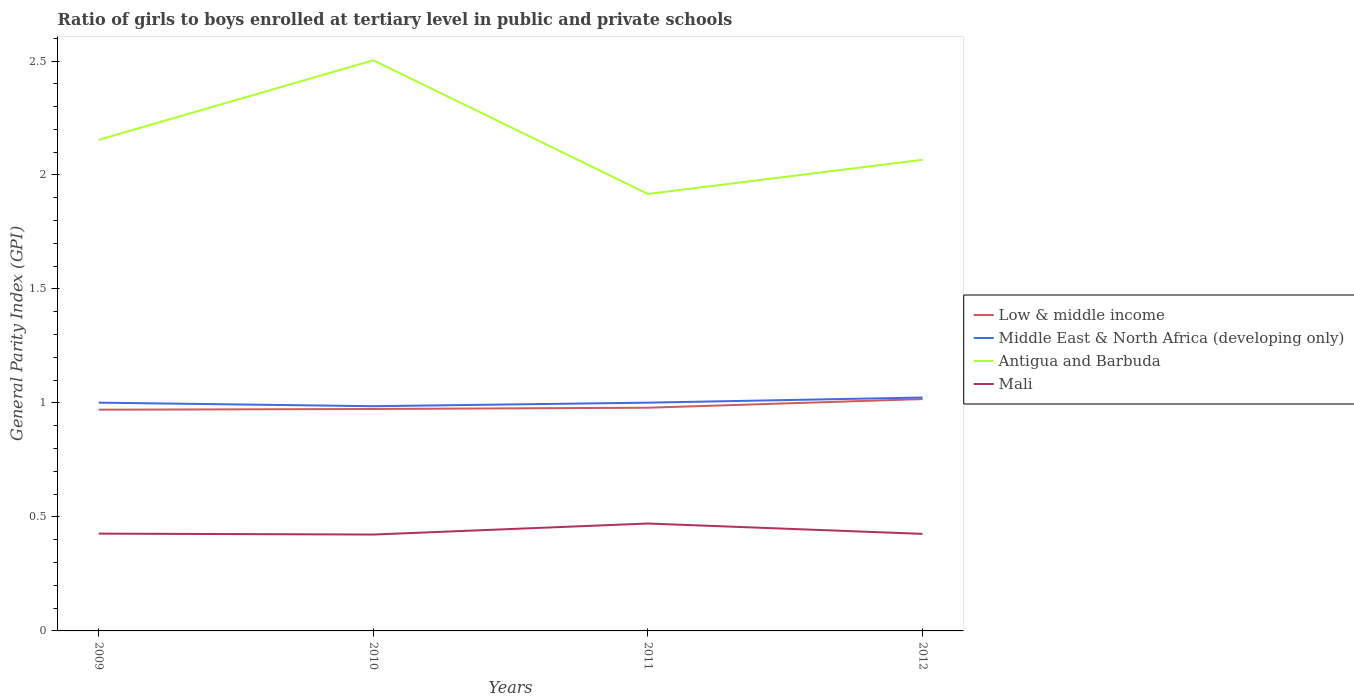Does the line corresponding to Middle East & North Africa (developing only) intersect with the line corresponding to Mali?
Provide a succinct answer. No. Is the number of lines equal to the number of legend labels?
Keep it short and to the point. Yes. Across all years, what is the maximum general parity index in Antigua and Barbuda?
Provide a succinct answer. 1.92. In which year was the general parity index in Low & middle income maximum?
Make the answer very short. 2009. What is the total general parity index in Low & middle income in the graph?
Provide a succinct answer. -0.04. What is the difference between the highest and the second highest general parity index in Low & middle income?
Provide a short and direct response. 0.05. What is the difference between the highest and the lowest general parity index in Antigua and Barbuda?
Provide a short and direct response. 1. Is the general parity index in Middle East & North Africa (developing only) strictly greater than the general parity index in Low & middle income over the years?
Give a very brief answer. No. How many lines are there?
Your response must be concise. 4. What is the difference between two consecutive major ticks on the Y-axis?
Provide a succinct answer. 0.5. Does the graph contain any zero values?
Ensure brevity in your answer.  No. Does the graph contain grids?
Your answer should be very brief. No. Where does the legend appear in the graph?
Your response must be concise. Center right. What is the title of the graph?
Ensure brevity in your answer.  Ratio of girls to boys enrolled at tertiary level in public and private schools. What is the label or title of the Y-axis?
Give a very brief answer. General Parity Index (GPI). What is the General Parity Index (GPI) in Low & middle income in 2009?
Ensure brevity in your answer.  0.97. What is the General Parity Index (GPI) of Middle East & North Africa (developing only) in 2009?
Provide a succinct answer. 1. What is the General Parity Index (GPI) of Antigua and Barbuda in 2009?
Provide a short and direct response. 2.15. What is the General Parity Index (GPI) in Mali in 2009?
Provide a short and direct response. 0.43. What is the General Parity Index (GPI) in Low & middle income in 2010?
Make the answer very short. 0.97. What is the General Parity Index (GPI) in Middle East & North Africa (developing only) in 2010?
Provide a succinct answer. 0.99. What is the General Parity Index (GPI) of Antigua and Barbuda in 2010?
Offer a very short reply. 2.5. What is the General Parity Index (GPI) in Mali in 2010?
Your response must be concise. 0.42. What is the General Parity Index (GPI) of Low & middle income in 2011?
Offer a very short reply. 0.98. What is the General Parity Index (GPI) of Middle East & North Africa (developing only) in 2011?
Ensure brevity in your answer.  1. What is the General Parity Index (GPI) of Antigua and Barbuda in 2011?
Ensure brevity in your answer.  1.92. What is the General Parity Index (GPI) of Mali in 2011?
Your response must be concise. 0.47. What is the General Parity Index (GPI) of Low & middle income in 2012?
Provide a succinct answer. 1.02. What is the General Parity Index (GPI) of Middle East & North Africa (developing only) in 2012?
Make the answer very short. 1.02. What is the General Parity Index (GPI) in Antigua and Barbuda in 2012?
Keep it short and to the point. 2.07. What is the General Parity Index (GPI) of Mali in 2012?
Make the answer very short. 0.43. Across all years, what is the maximum General Parity Index (GPI) of Low & middle income?
Your answer should be very brief. 1.02. Across all years, what is the maximum General Parity Index (GPI) in Middle East & North Africa (developing only)?
Make the answer very short. 1.02. Across all years, what is the maximum General Parity Index (GPI) of Antigua and Barbuda?
Your answer should be very brief. 2.5. Across all years, what is the maximum General Parity Index (GPI) of Mali?
Ensure brevity in your answer.  0.47. Across all years, what is the minimum General Parity Index (GPI) of Low & middle income?
Your response must be concise. 0.97. Across all years, what is the minimum General Parity Index (GPI) of Middle East & North Africa (developing only)?
Your answer should be very brief. 0.99. Across all years, what is the minimum General Parity Index (GPI) in Antigua and Barbuda?
Give a very brief answer. 1.92. Across all years, what is the minimum General Parity Index (GPI) of Mali?
Provide a succinct answer. 0.42. What is the total General Parity Index (GPI) of Low & middle income in the graph?
Provide a succinct answer. 3.94. What is the total General Parity Index (GPI) of Middle East & North Africa (developing only) in the graph?
Offer a very short reply. 4.01. What is the total General Parity Index (GPI) in Antigua and Barbuda in the graph?
Provide a succinct answer. 8.64. What is the total General Parity Index (GPI) of Mali in the graph?
Ensure brevity in your answer.  1.75. What is the difference between the General Parity Index (GPI) in Low & middle income in 2009 and that in 2010?
Your answer should be compact. -0. What is the difference between the General Parity Index (GPI) in Middle East & North Africa (developing only) in 2009 and that in 2010?
Ensure brevity in your answer.  0.02. What is the difference between the General Parity Index (GPI) of Antigua and Barbuda in 2009 and that in 2010?
Offer a very short reply. -0.35. What is the difference between the General Parity Index (GPI) in Mali in 2009 and that in 2010?
Keep it short and to the point. 0. What is the difference between the General Parity Index (GPI) of Low & middle income in 2009 and that in 2011?
Your answer should be very brief. -0.01. What is the difference between the General Parity Index (GPI) in Antigua and Barbuda in 2009 and that in 2011?
Your answer should be compact. 0.24. What is the difference between the General Parity Index (GPI) of Mali in 2009 and that in 2011?
Offer a terse response. -0.04. What is the difference between the General Parity Index (GPI) in Low & middle income in 2009 and that in 2012?
Keep it short and to the point. -0.05. What is the difference between the General Parity Index (GPI) in Middle East & North Africa (developing only) in 2009 and that in 2012?
Your response must be concise. -0.02. What is the difference between the General Parity Index (GPI) of Antigua and Barbuda in 2009 and that in 2012?
Your answer should be very brief. 0.09. What is the difference between the General Parity Index (GPI) of Mali in 2009 and that in 2012?
Keep it short and to the point. 0. What is the difference between the General Parity Index (GPI) in Low & middle income in 2010 and that in 2011?
Offer a very short reply. -0.01. What is the difference between the General Parity Index (GPI) of Middle East & North Africa (developing only) in 2010 and that in 2011?
Make the answer very short. -0.02. What is the difference between the General Parity Index (GPI) of Antigua and Barbuda in 2010 and that in 2011?
Offer a terse response. 0.59. What is the difference between the General Parity Index (GPI) in Mali in 2010 and that in 2011?
Offer a very short reply. -0.05. What is the difference between the General Parity Index (GPI) of Low & middle income in 2010 and that in 2012?
Make the answer very short. -0.04. What is the difference between the General Parity Index (GPI) of Middle East & North Africa (developing only) in 2010 and that in 2012?
Ensure brevity in your answer.  -0.04. What is the difference between the General Parity Index (GPI) of Antigua and Barbuda in 2010 and that in 2012?
Ensure brevity in your answer.  0.44. What is the difference between the General Parity Index (GPI) in Mali in 2010 and that in 2012?
Your answer should be very brief. -0. What is the difference between the General Parity Index (GPI) in Low & middle income in 2011 and that in 2012?
Your answer should be compact. -0.04. What is the difference between the General Parity Index (GPI) of Middle East & North Africa (developing only) in 2011 and that in 2012?
Offer a terse response. -0.02. What is the difference between the General Parity Index (GPI) of Antigua and Barbuda in 2011 and that in 2012?
Offer a very short reply. -0.15. What is the difference between the General Parity Index (GPI) of Mali in 2011 and that in 2012?
Make the answer very short. 0.05. What is the difference between the General Parity Index (GPI) of Low & middle income in 2009 and the General Parity Index (GPI) of Middle East & North Africa (developing only) in 2010?
Your answer should be very brief. -0.02. What is the difference between the General Parity Index (GPI) of Low & middle income in 2009 and the General Parity Index (GPI) of Antigua and Barbuda in 2010?
Provide a short and direct response. -1.53. What is the difference between the General Parity Index (GPI) in Low & middle income in 2009 and the General Parity Index (GPI) in Mali in 2010?
Give a very brief answer. 0.55. What is the difference between the General Parity Index (GPI) of Middle East & North Africa (developing only) in 2009 and the General Parity Index (GPI) of Antigua and Barbuda in 2010?
Your response must be concise. -1.5. What is the difference between the General Parity Index (GPI) in Middle East & North Africa (developing only) in 2009 and the General Parity Index (GPI) in Mali in 2010?
Offer a very short reply. 0.58. What is the difference between the General Parity Index (GPI) in Antigua and Barbuda in 2009 and the General Parity Index (GPI) in Mali in 2010?
Offer a very short reply. 1.73. What is the difference between the General Parity Index (GPI) in Low & middle income in 2009 and the General Parity Index (GPI) in Middle East & North Africa (developing only) in 2011?
Provide a short and direct response. -0.03. What is the difference between the General Parity Index (GPI) in Low & middle income in 2009 and the General Parity Index (GPI) in Antigua and Barbuda in 2011?
Give a very brief answer. -0.95. What is the difference between the General Parity Index (GPI) of Low & middle income in 2009 and the General Parity Index (GPI) of Mali in 2011?
Your answer should be compact. 0.5. What is the difference between the General Parity Index (GPI) of Middle East & North Africa (developing only) in 2009 and the General Parity Index (GPI) of Antigua and Barbuda in 2011?
Offer a terse response. -0.92. What is the difference between the General Parity Index (GPI) in Middle East & North Africa (developing only) in 2009 and the General Parity Index (GPI) in Mali in 2011?
Give a very brief answer. 0.53. What is the difference between the General Parity Index (GPI) in Antigua and Barbuda in 2009 and the General Parity Index (GPI) in Mali in 2011?
Provide a succinct answer. 1.68. What is the difference between the General Parity Index (GPI) in Low & middle income in 2009 and the General Parity Index (GPI) in Middle East & North Africa (developing only) in 2012?
Offer a very short reply. -0.05. What is the difference between the General Parity Index (GPI) in Low & middle income in 2009 and the General Parity Index (GPI) in Antigua and Barbuda in 2012?
Your response must be concise. -1.1. What is the difference between the General Parity Index (GPI) of Low & middle income in 2009 and the General Parity Index (GPI) of Mali in 2012?
Provide a succinct answer. 0.54. What is the difference between the General Parity Index (GPI) in Middle East & North Africa (developing only) in 2009 and the General Parity Index (GPI) in Antigua and Barbuda in 2012?
Keep it short and to the point. -1.07. What is the difference between the General Parity Index (GPI) in Middle East & North Africa (developing only) in 2009 and the General Parity Index (GPI) in Mali in 2012?
Your answer should be very brief. 0.58. What is the difference between the General Parity Index (GPI) in Antigua and Barbuda in 2009 and the General Parity Index (GPI) in Mali in 2012?
Your answer should be compact. 1.73. What is the difference between the General Parity Index (GPI) of Low & middle income in 2010 and the General Parity Index (GPI) of Middle East & North Africa (developing only) in 2011?
Your answer should be compact. -0.03. What is the difference between the General Parity Index (GPI) in Low & middle income in 2010 and the General Parity Index (GPI) in Antigua and Barbuda in 2011?
Keep it short and to the point. -0.94. What is the difference between the General Parity Index (GPI) in Low & middle income in 2010 and the General Parity Index (GPI) in Mali in 2011?
Your answer should be compact. 0.5. What is the difference between the General Parity Index (GPI) in Middle East & North Africa (developing only) in 2010 and the General Parity Index (GPI) in Antigua and Barbuda in 2011?
Offer a very short reply. -0.93. What is the difference between the General Parity Index (GPI) in Middle East & North Africa (developing only) in 2010 and the General Parity Index (GPI) in Mali in 2011?
Your answer should be compact. 0.51. What is the difference between the General Parity Index (GPI) of Antigua and Barbuda in 2010 and the General Parity Index (GPI) of Mali in 2011?
Offer a terse response. 2.03. What is the difference between the General Parity Index (GPI) of Low & middle income in 2010 and the General Parity Index (GPI) of Middle East & North Africa (developing only) in 2012?
Make the answer very short. -0.05. What is the difference between the General Parity Index (GPI) in Low & middle income in 2010 and the General Parity Index (GPI) in Antigua and Barbuda in 2012?
Offer a terse response. -1.09. What is the difference between the General Parity Index (GPI) in Low & middle income in 2010 and the General Parity Index (GPI) in Mali in 2012?
Give a very brief answer. 0.55. What is the difference between the General Parity Index (GPI) in Middle East & North Africa (developing only) in 2010 and the General Parity Index (GPI) in Antigua and Barbuda in 2012?
Your answer should be compact. -1.08. What is the difference between the General Parity Index (GPI) of Middle East & North Africa (developing only) in 2010 and the General Parity Index (GPI) of Mali in 2012?
Make the answer very short. 0.56. What is the difference between the General Parity Index (GPI) in Antigua and Barbuda in 2010 and the General Parity Index (GPI) in Mali in 2012?
Your answer should be very brief. 2.08. What is the difference between the General Parity Index (GPI) of Low & middle income in 2011 and the General Parity Index (GPI) of Middle East & North Africa (developing only) in 2012?
Provide a short and direct response. -0.04. What is the difference between the General Parity Index (GPI) in Low & middle income in 2011 and the General Parity Index (GPI) in Antigua and Barbuda in 2012?
Make the answer very short. -1.09. What is the difference between the General Parity Index (GPI) of Low & middle income in 2011 and the General Parity Index (GPI) of Mali in 2012?
Your answer should be very brief. 0.55. What is the difference between the General Parity Index (GPI) of Middle East & North Africa (developing only) in 2011 and the General Parity Index (GPI) of Antigua and Barbuda in 2012?
Offer a very short reply. -1.07. What is the difference between the General Parity Index (GPI) of Middle East & North Africa (developing only) in 2011 and the General Parity Index (GPI) of Mali in 2012?
Ensure brevity in your answer.  0.58. What is the difference between the General Parity Index (GPI) in Antigua and Barbuda in 2011 and the General Parity Index (GPI) in Mali in 2012?
Provide a succinct answer. 1.49. What is the average General Parity Index (GPI) of Low & middle income per year?
Keep it short and to the point. 0.98. What is the average General Parity Index (GPI) of Middle East & North Africa (developing only) per year?
Give a very brief answer. 1. What is the average General Parity Index (GPI) in Antigua and Barbuda per year?
Make the answer very short. 2.16. What is the average General Parity Index (GPI) of Mali per year?
Make the answer very short. 0.44. In the year 2009, what is the difference between the General Parity Index (GPI) of Low & middle income and General Parity Index (GPI) of Middle East & North Africa (developing only)?
Offer a very short reply. -0.03. In the year 2009, what is the difference between the General Parity Index (GPI) of Low & middle income and General Parity Index (GPI) of Antigua and Barbuda?
Your response must be concise. -1.18. In the year 2009, what is the difference between the General Parity Index (GPI) of Low & middle income and General Parity Index (GPI) of Mali?
Your answer should be very brief. 0.54. In the year 2009, what is the difference between the General Parity Index (GPI) in Middle East & North Africa (developing only) and General Parity Index (GPI) in Antigua and Barbuda?
Keep it short and to the point. -1.15. In the year 2009, what is the difference between the General Parity Index (GPI) of Middle East & North Africa (developing only) and General Parity Index (GPI) of Mali?
Provide a short and direct response. 0.57. In the year 2009, what is the difference between the General Parity Index (GPI) of Antigua and Barbuda and General Parity Index (GPI) of Mali?
Offer a very short reply. 1.73. In the year 2010, what is the difference between the General Parity Index (GPI) in Low & middle income and General Parity Index (GPI) in Middle East & North Africa (developing only)?
Your response must be concise. -0.01. In the year 2010, what is the difference between the General Parity Index (GPI) of Low & middle income and General Parity Index (GPI) of Antigua and Barbuda?
Provide a succinct answer. -1.53. In the year 2010, what is the difference between the General Parity Index (GPI) in Low & middle income and General Parity Index (GPI) in Mali?
Your answer should be very brief. 0.55. In the year 2010, what is the difference between the General Parity Index (GPI) of Middle East & North Africa (developing only) and General Parity Index (GPI) of Antigua and Barbuda?
Your response must be concise. -1.52. In the year 2010, what is the difference between the General Parity Index (GPI) in Middle East & North Africa (developing only) and General Parity Index (GPI) in Mali?
Your response must be concise. 0.56. In the year 2010, what is the difference between the General Parity Index (GPI) in Antigua and Barbuda and General Parity Index (GPI) in Mali?
Ensure brevity in your answer.  2.08. In the year 2011, what is the difference between the General Parity Index (GPI) of Low & middle income and General Parity Index (GPI) of Middle East & North Africa (developing only)?
Provide a succinct answer. -0.02. In the year 2011, what is the difference between the General Parity Index (GPI) of Low & middle income and General Parity Index (GPI) of Antigua and Barbuda?
Your answer should be very brief. -0.94. In the year 2011, what is the difference between the General Parity Index (GPI) of Low & middle income and General Parity Index (GPI) of Mali?
Offer a very short reply. 0.51. In the year 2011, what is the difference between the General Parity Index (GPI) of Middle East & North Africa (developing only) and General Parity Index (GPI) of Antigua and Barbuda?
Make the answer very short. -0.92. In the year 2011, what is the difference between the General Parity Index (GPI) of Middle East & North Africa (developing only) and General Parity Index (GPI) of Mali?
Provide a short and direct response. 0.53. In the year 2011, what is the difference between the General Parity Index (GPI) of Antigua and Barbuda and General Parity Index (GPI) of Mali?
Your answer should be very brief. 1.45. In the year 2012, what is the difference between the General Parity Index (GPI) in Low & middle income and General Parity Index (GPI) in Middle East & North Africa (developing only)?
Offer a very short reply. -0.01. In the year 2012, what is the difference between the General Parity Index (GPI) in Low & middle income and General Parity Index (GPI) in Antigua and Barbuda?
Offer a terse response. -1.05. In the year 2012, what is the difference between the General Parity Index (GPI) in Low & middle income and General Parity Index (GPI) in Mali?
Ensure brevity in your answer.  0.59. In the year 2012, what is the difference between the General Parity Index (GPI) of Middle East & North Africa (developing only) and General Parity Index (GPI) of Antigua and Barbuda?
Offer a very short reply. -1.04. In the year 2012, what is the difference between the General Parity Index (GPI) of Middle East & North Africa (developing only) and General Parity Index (GPI) of Mali?
Offer a terse response. 0.6. In the year 2012, what is the difference between the General Parity Index (GPI) of Antigua and Barbuda and General Parity Index (GPI) of Mali?
Your response must be concise. 1.64. What is the ratio of the General Parity Index (GPI) of Middle East & North Africa (developing only) in 2009 to that in 2010?
Give a very brief answer. 1.02. What is the ratio of the General Parity Index (GPI) in Antigua and Barbuda in 2009 to that in 2010?
Make the answer very short. 0.86. What is the ratio of the General Parity Index (GPI) in Mali in 2009 to that in 2010?
Make the answer very short. 1.01. What is the ratio of the General Parity Index (GPI) in Antigua and Barbuda in 2009 to that in 2011?
Offer a very short reply. 1.12. What is the ratio of the General Parity Index (GPI) of Mali in 2009 to that in 2011?
Provide a short and direct response. 0.91. What is the ratio of the General Parity Index (GPI) of Low & middle income in 2009 to that in 2012?
Keep it short and to the point. 0.95. What is the ratio of the General Parity Index (GPI) in Middle East & North Africa (developing only) in 2009 to that in 2012?
Offer a terse response. 0.98. What is the ratio of the General Parity Index (GPI) of Antigua and Barbuda in 2009 to that in 2012?
Give a very brief answer. 1.04. What is the ratio of the General Parity Index (GPI) of Low & middle income in 2010 to that in 2011?
Your answer should be very brief. 0.99. What is the ratio of the General Parity Index (GPI) of Middle East & North Africa (developing only) in 2010 to that in 2011?
Give a very brief answer. 0.98. What is the ratio of the General Parity Index (GPI) in Antigua and Barbuda in 2010 to that in 2011?
Offer a terse response. 1.31. What is the ratio of the General Parity Index (GPI) in Mali in 2010 to that in 2011?
Provide a succinct answer. 0.9. What is the ratio of the General Parity Index (GPI) of Low & middle income in 2010 to that in 2012?
Ensure brevity in your answer.  0.96. What is the ratio of the General Parity Index (GPI) of Middle East & North Africa (developing only) in 2010 to that in 2012?
Ensure brevity in your answer.  0.96. What is the ratio of the General Parity Index (GPI) in Antigua and Barbuda in 2010 to that in 2012?
Keep it short and to the point. 1.21. What is the ratio of the General Parity Index (GPI) of Mali in 2010 to that in 2012?
Offer a very short reply. 0.99. What is the ratio of the General Parity Index (GPI) of Low & middle income in 2011 to that in 2012?
Keep it short and to the point. 0.96. What is the ratio of the General Parity Index (GPI) of Middle East & North Africa (developing only) in 2011 to that in 2012?
Ensure brevity in your answer.  0.98. What is the ratio of the General Parity Index (GPI) in Antigua and Barbuda in 2011 to that in 2012?
Your answer should be very brief. 0.93. What is the ratio of the General Parity Index (GPI) of Mali in 2011 to that in 2012?
Make the answer very short. 1.11. What is the difference between the highest and the second highest General Parity Index (GPI) in Low & middle income?
Provide a short and direct response. 0.04. What is the difference between the highest and the second highest General Parity Index (GPI) in Middle East & North Africa (developing only)?
Your answer should be compact. 0.02. What is the difference between the highest and the second highest General Parity Index (GPI) in Antigua and Barbuda?
Your response must be concise. 0.35. What is the difference between the highest and the second highest General Parity Index (GPI) of Mali?
Your answer should be compact. 0.04. What is the difference between the highest and the lowest General Parity Index (GPI) in Low & middle income?
Your answer should be very brief. 0.05. What is the difference between the highest and the lowest General Parity Index (GPI) of Middle East & North Africa (developing only)?
Your answer should be very brief. 0.04. What is the difference between the highest and the lowest General Parity Index (GPI) in Antigua and Barbuda?
Your response must be concise. 0.59. What is the difference between the highest and the lowest General Parity Index (GPI) of Mali?
Provide a succinct answer. 0.05. 